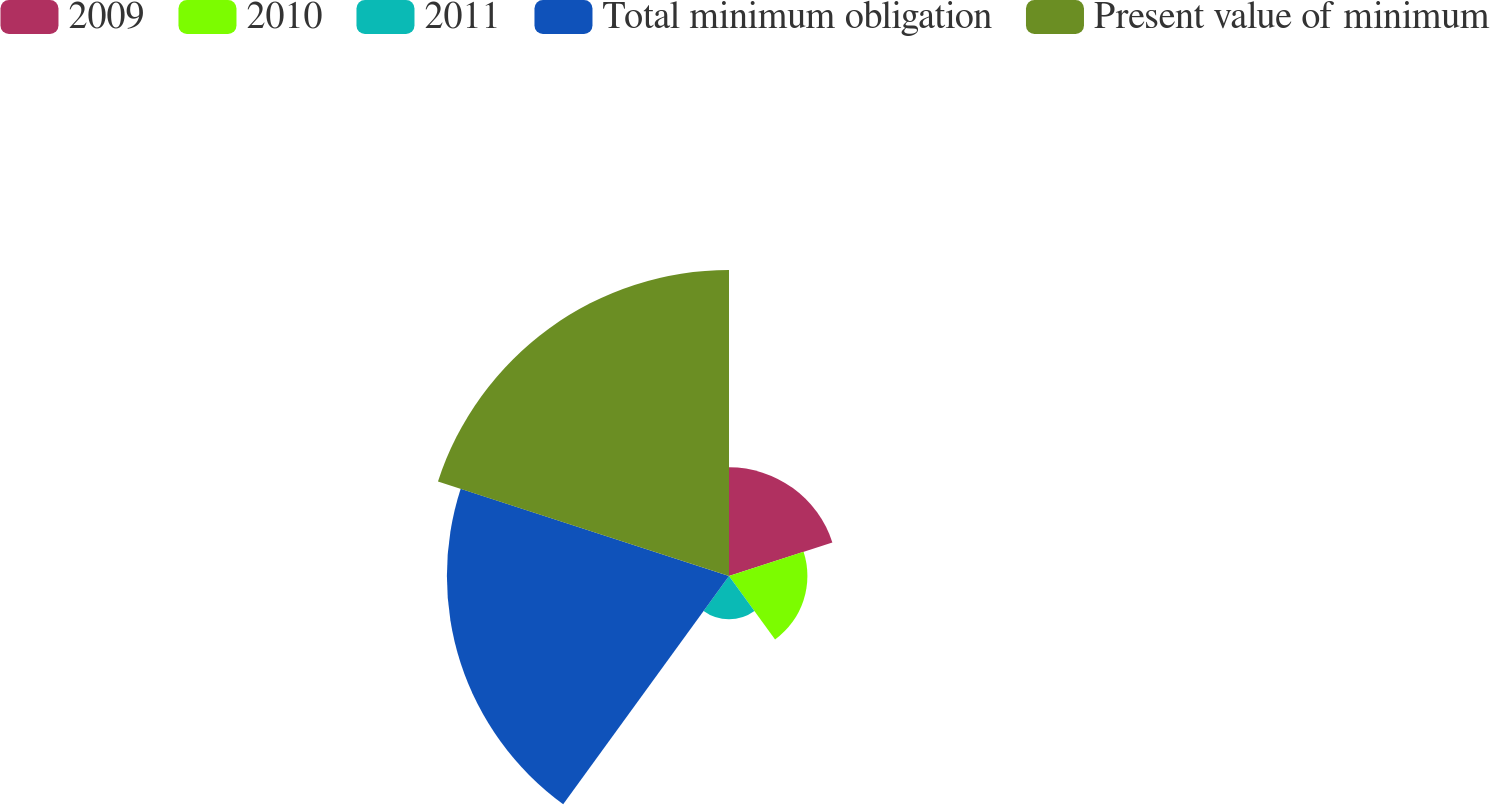Convert chart. <chart><loc_0><loc_0><loc_500><loc_500><pie_chart><fcel>2009<fcel>2010<fcel>2011<fcel>Total minimum obligation<fcel>Present value of minimum<nl><fcel>13.28%<fcel>9.58%<fcel>5.29%<fcel>34.47%<fcel>37.39%<nl></chart> 